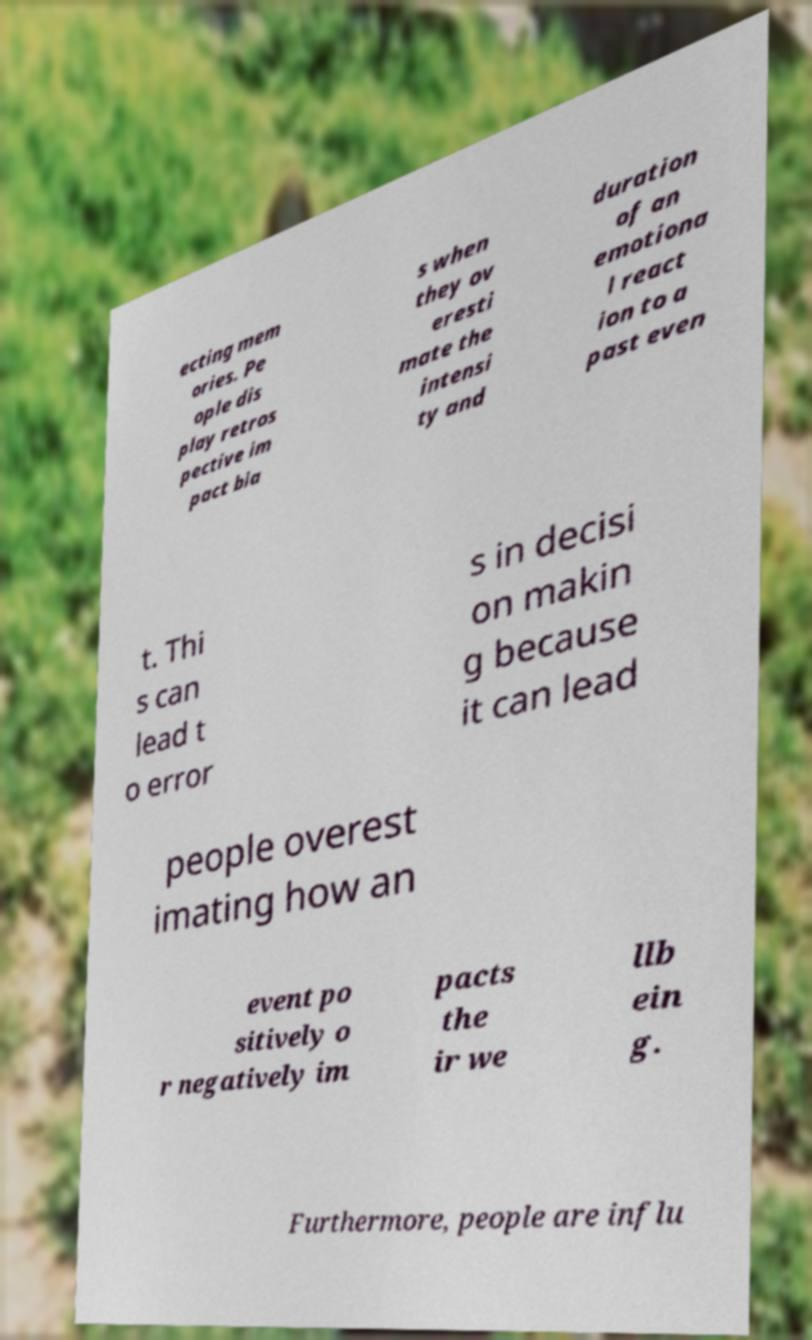Could you extract and type out the text from this image? ecting mem ories. Pe ople dis play retros pective im pact bia s when they ov eresti mate the intensi ty and duration of an emotiona l react ion to a past even t. Thi s can lead t o error s in decisi on makin g because it can lead people overest imating how an event po sitively o r negatively im pacts the ir we llb ein g. Furthermore, people are influ 